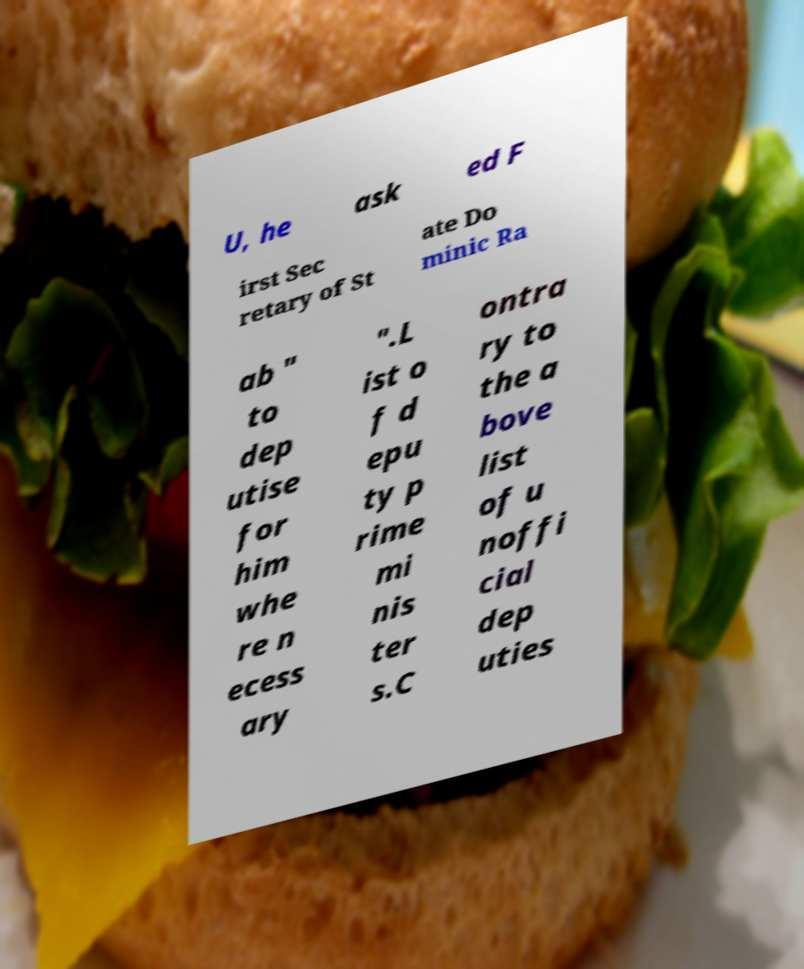Could you assist in decoding the text presented in this image and type it out clearly? U, he ask ed F irst Sec retary of St ate Do minic Ra ab " to dep utise for him whe re n ecess ary ".L ist o f d epu ty p rime mi nis ter s.C ontra ry to the a bove list of u noffi cial dep uties 